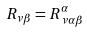<formula> <loc_0><loc_0><loc_500><loc_500>R _ { \nu \beta } = R ^ { \alpha } _ { \, \nu \alpha \beta }</formula> 